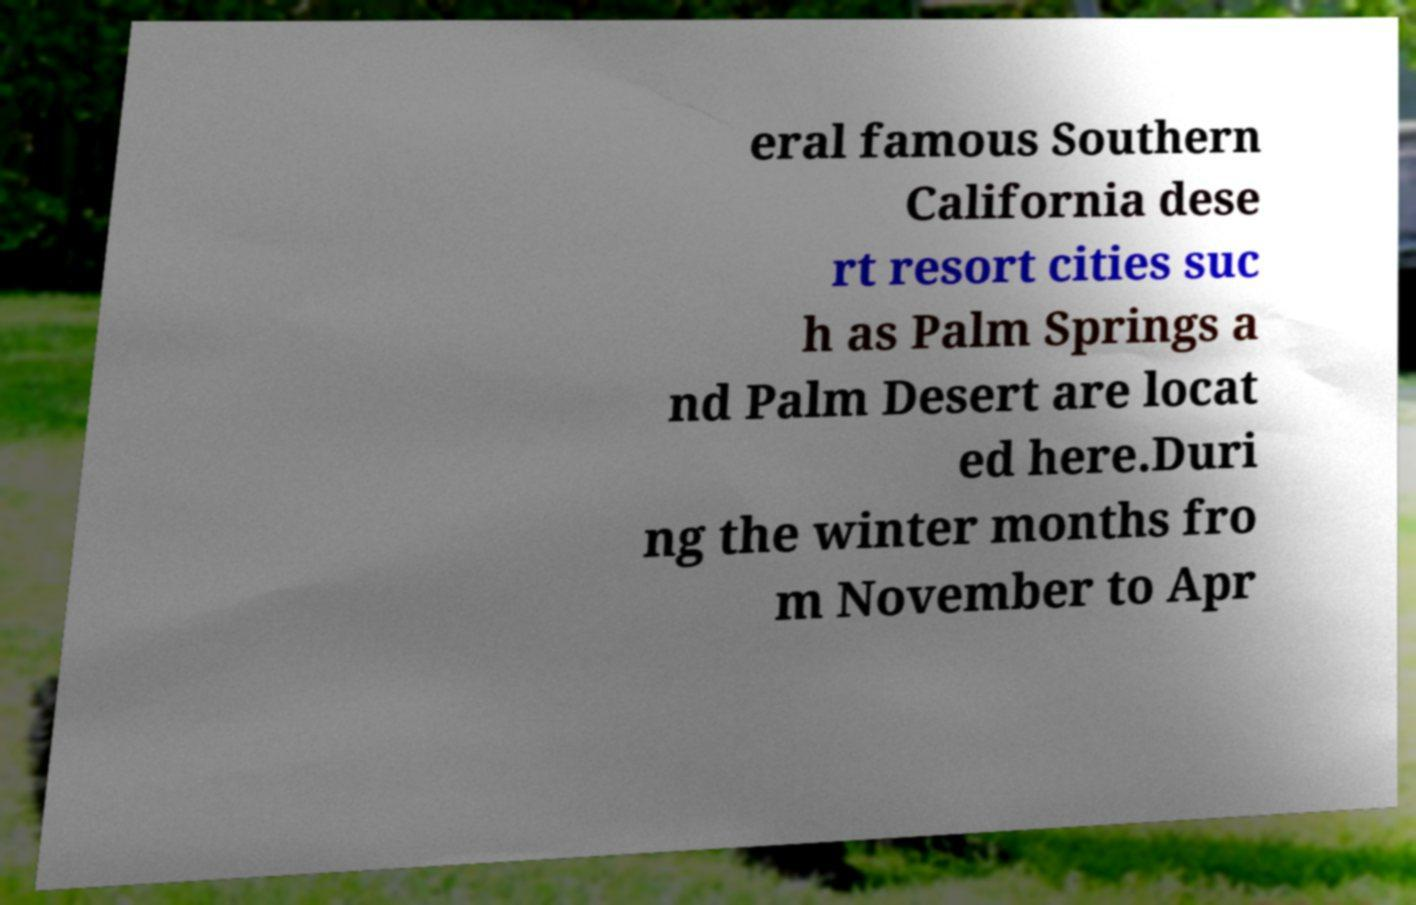Can you read and provide the text displayed in the image?This photo seems to have some interesting text. Can you extract and type it out for me? eral famous Southern California dese rt resort cities suc h as Palm Springs a nd Palm Desert are locat ed here.Duri ng the winter months fro m November to Apr 